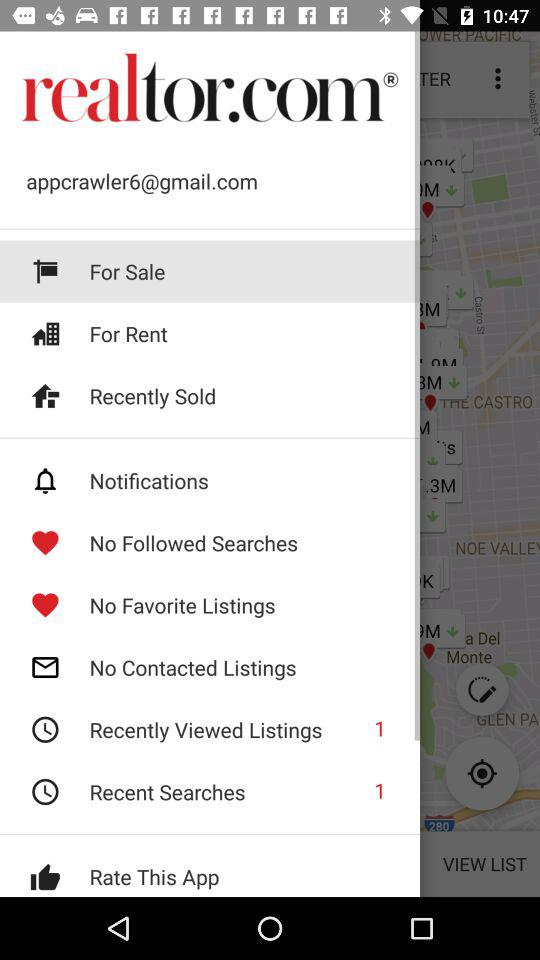What is the email address? The email address is appcrawler6@gmail.com. 